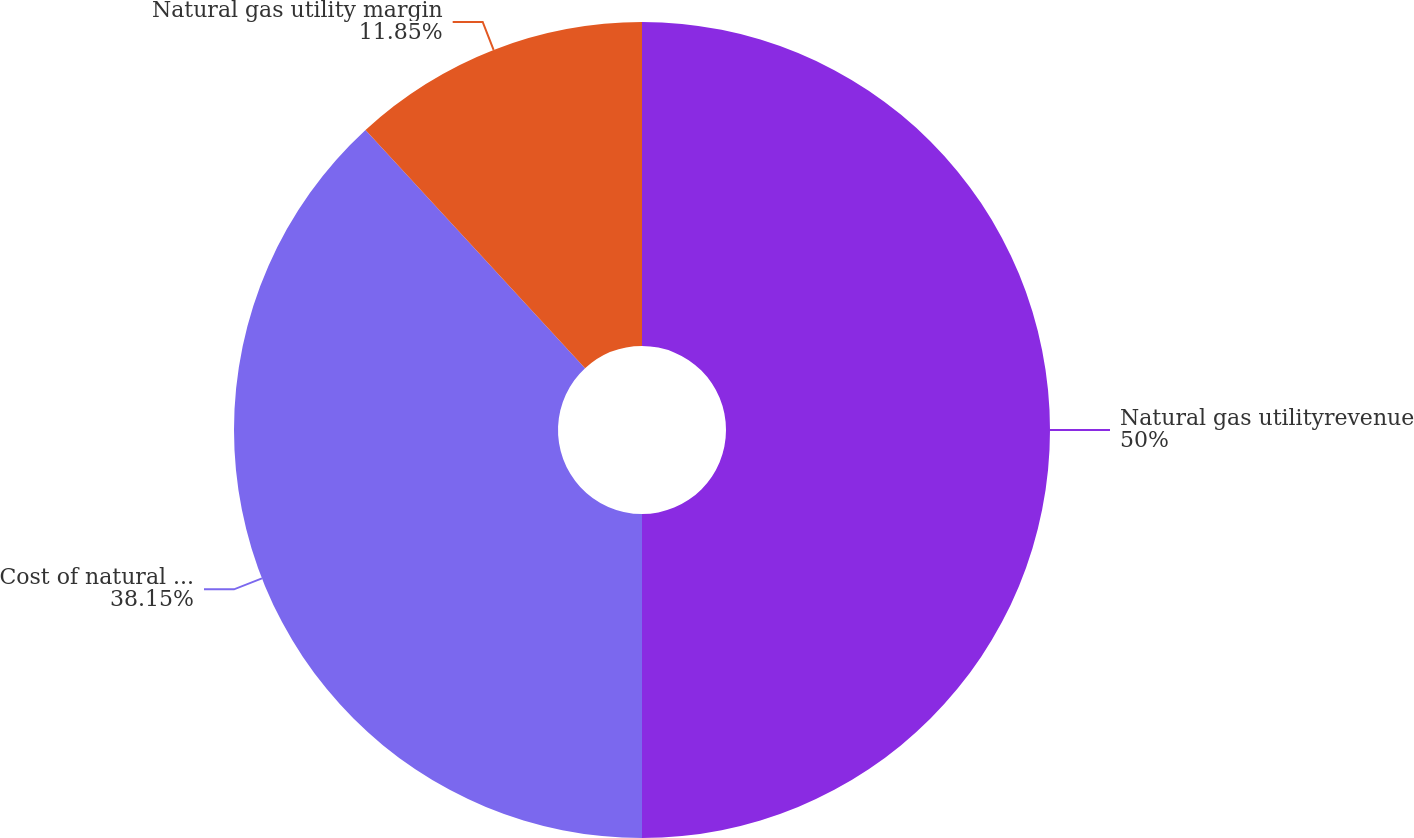<chart> <loc_0><loc_0><loc_500><loc_500><pie_chart><fcel>Natural gas utilityrevenue<fcel>Cost of natural gas purchased<fcel>Natural gas utility margin<nl><fcel>50.0%<fcel>38.15%<fcel>11.85%<nl></chart> 